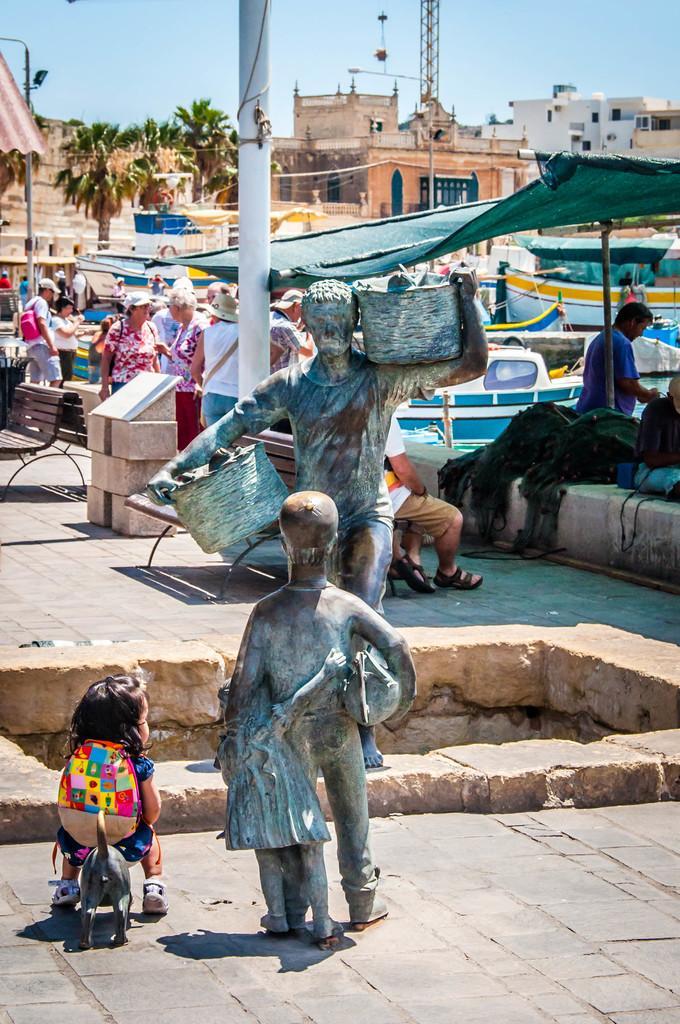How would you summarize this image in a sentence or two? In the center of the image sculptures are present. In the background of the image we can see the group of people are standing and also we can see bench, pole, trees, buildings, rent, boats, clothes, bag, tower are present. At the top of the image sky is there. At the bottom of the image ground is present. 